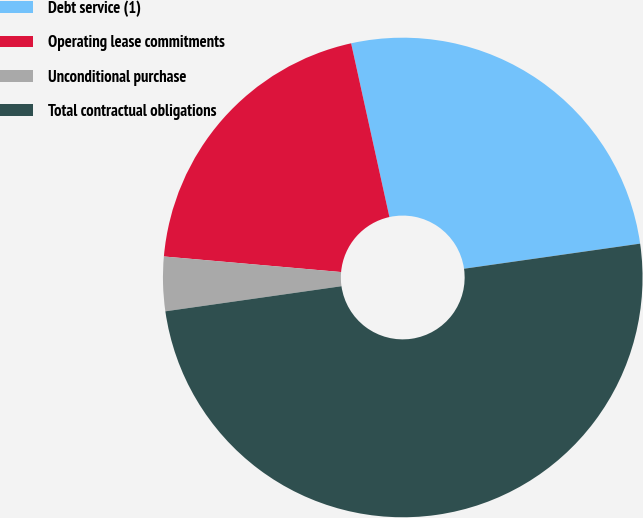Convert chart. <chart><loc_0><loc_0><loc_500><loc_500><pie_chart><fcel>Debt service (1)<fcel>Operating lease commitments<fcel>Unconditional purchase<fcel>Total contractual obligations<nl><fcel>26.2%<fcel>20.15%<fcel>3.65%<fcel>50.0%<nl></chart> 